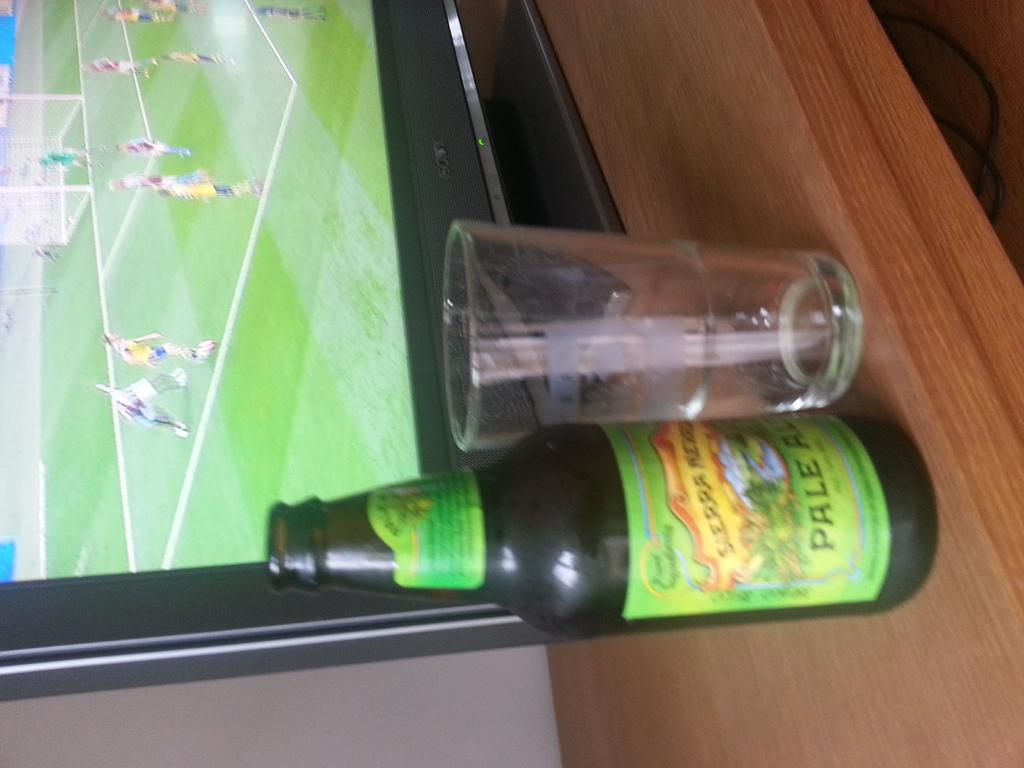<image>
Provide a brief description of the given image. A bottle of pale ale sits on a table next to a TV. 